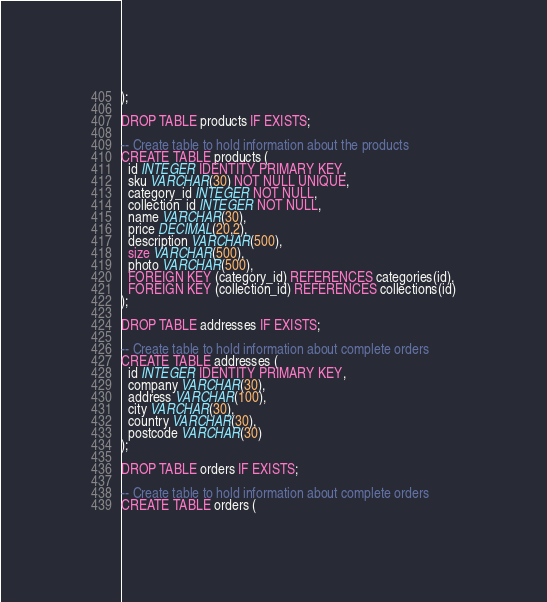<code> <loc_0><loc_0><loc_500><loc_500><_SQL_>);

DROP TABLE products IF EXISTS;

-- Create table to hold information about the products
CREATE TABLE products (
  id INTEGER IDENTITY PRIMARY KEY,
  sku VARCHAR(30) NOT NULL UNIQUE,
  category_id INTEGER NOT NULL,
  collection_id INTEGER NOT NULL,
  name VARCHAR(30),
  price DECIMAL(20,2),
  description VARCHAR(500),
  size VARCHAR(500),
  photo VARCHAR(500),
  FOREIGN KEY (category_id) REFERENCES categories(id),
  FOREIGN KEY (collection_id) REFERENCES collections(id)
);

DROP TABLE addresses IF EXISTS;

-- Create table to hold information about complete orders
CREATE TABLE addresses (
  id INTEGER IDENTITY PRIMARY KEY,
  company VARCHAR(30),
  address VARCHAR(100),
  city VARCHAR(30),
  country VARCHAR(30),
  postcode VARCHAR(30)
);

DROP TABLE orders IF EXISTS;

-- Create table to hold information about complete orders
CREATE TABLE orders (</code> 